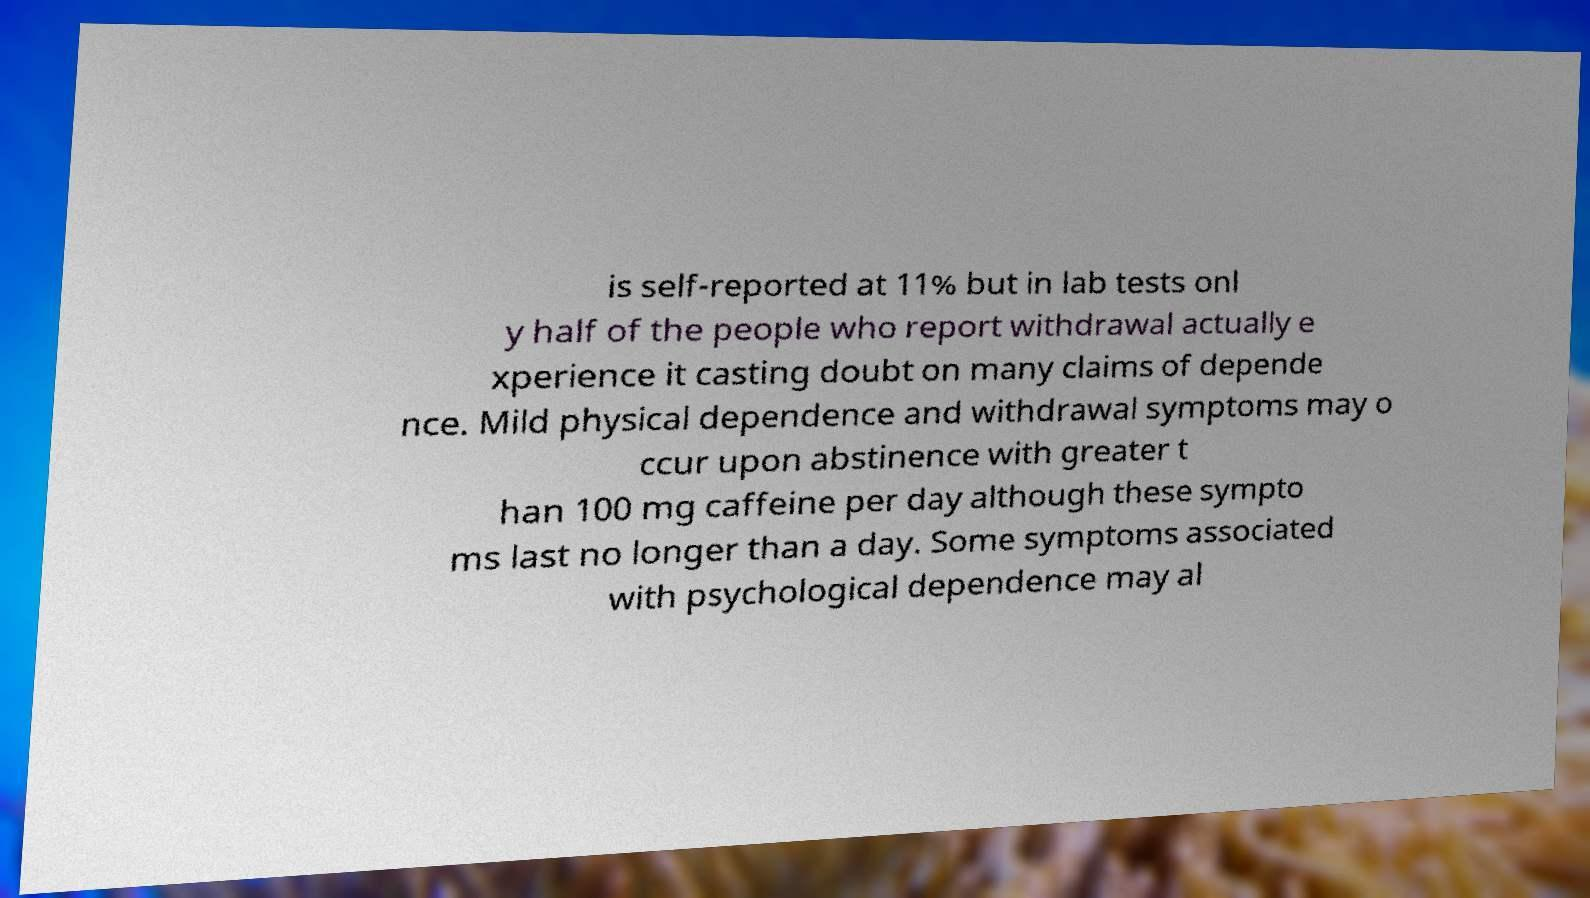For documentation purposes, I need the text within this image transcribed. Could you provide that? is self-reported at 11% but in lab tests onl y half of the people who report withdrawal actually e xperience it casting doubt on many claims of depende nce. Mild physical dependence and withdrawal symptoms may o ccur upon abstinence with greater t han 100 mg caffeine per day although these sympto ms last no longer than a day. Some symptoms associated with psychological dependence may al 